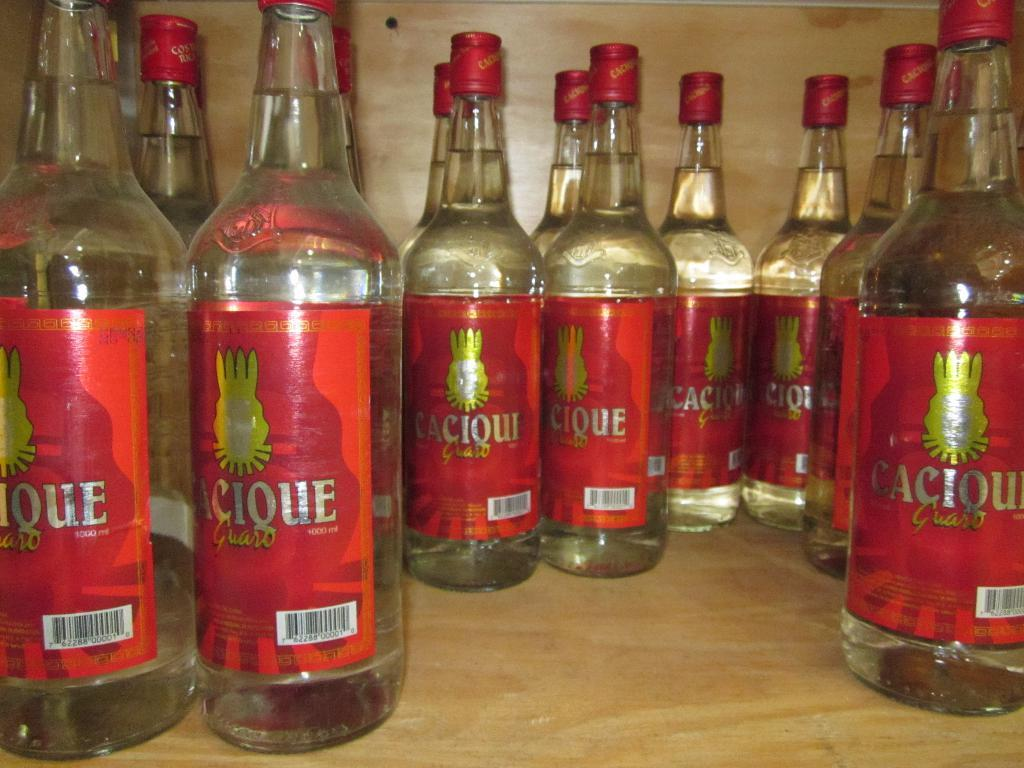<image>
Share a concise interpretation of the image provided. A group of bottles of alcohol that say Cacique on a wooden shelf. 